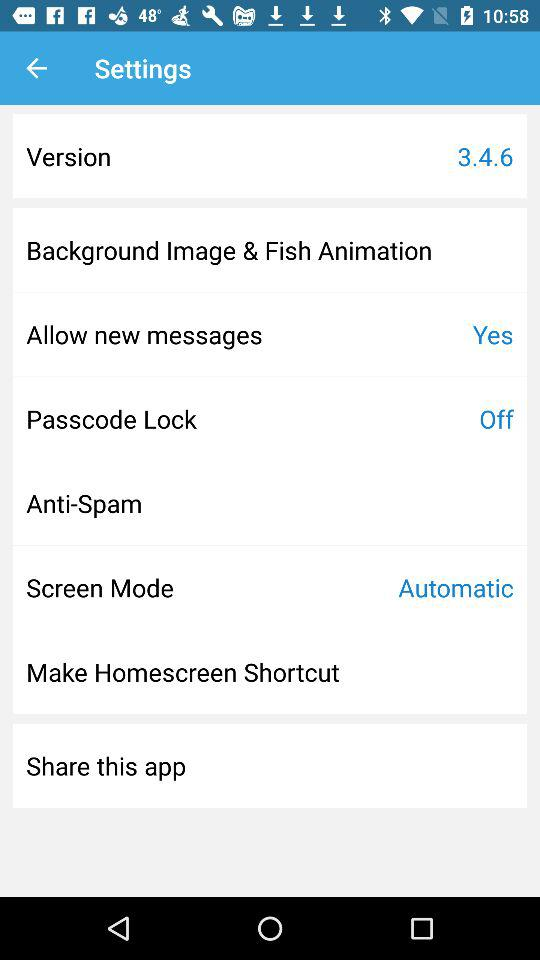What is the selected screen mode? The selected screen mode is "Automatic". 